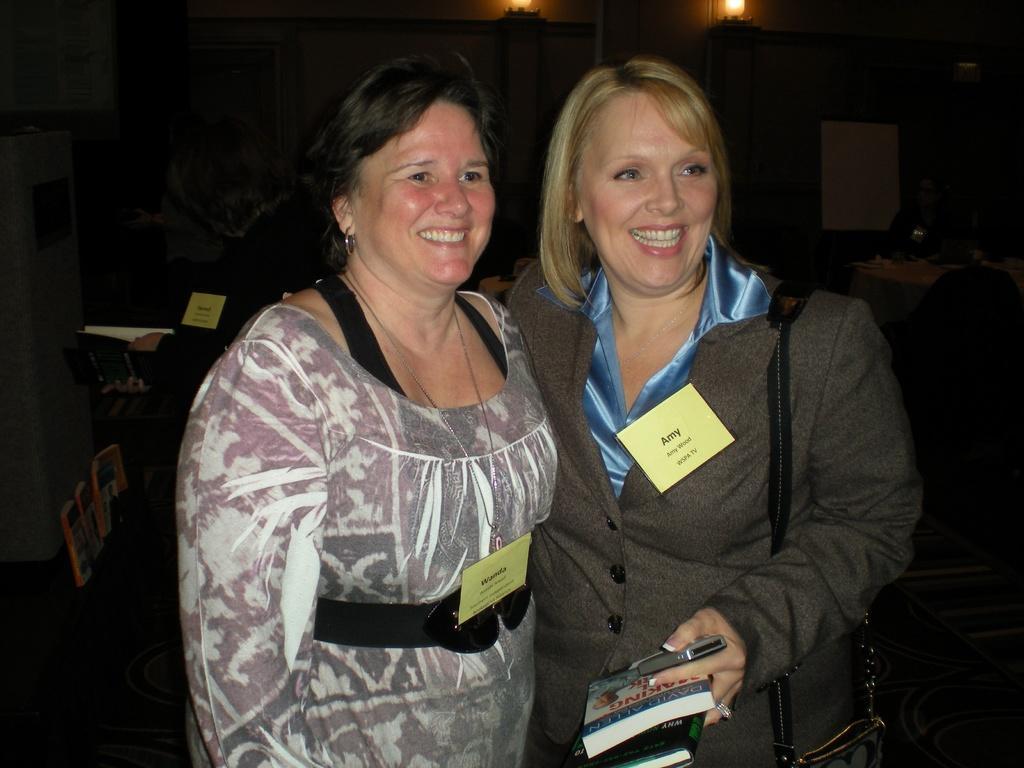Could you give a brief overview of what you see in this image? In this image, we can see persons wearing clothes. There is a person on the right side of the image holding a phone and book. There are lights at the top of the image. 